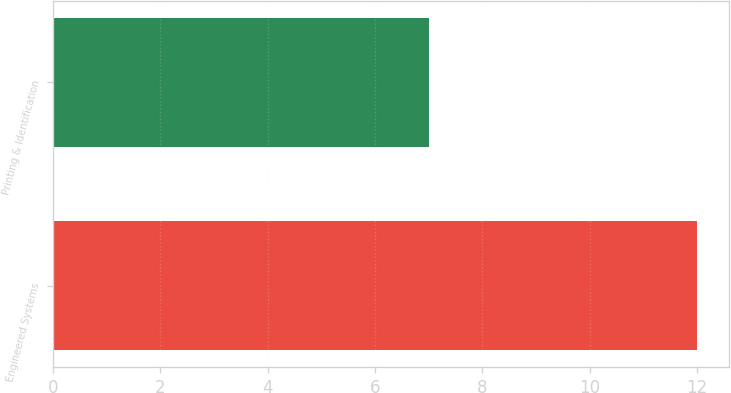Convert chart. <chart><loc_0><loc_0><loc_500><loc_500><bar_chart><fcel>Engineered Systems<fcel>Printing & Identification<nl><fcel>12<fcel>7<nl></chart> 